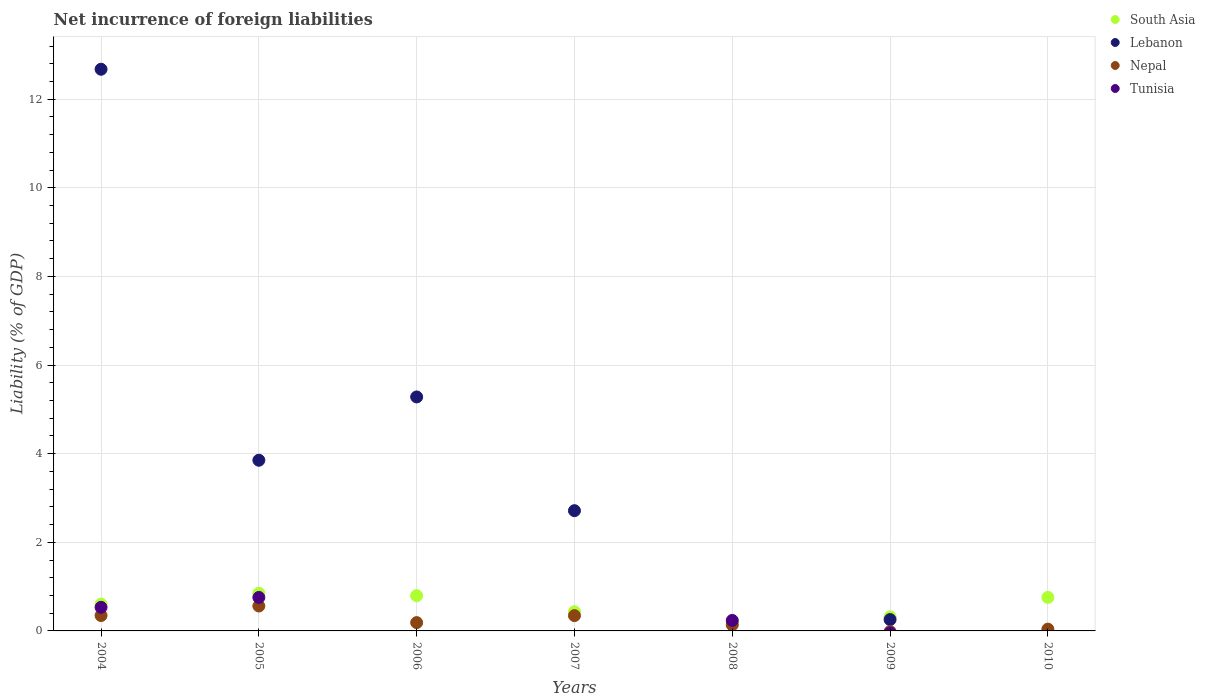How many different coloured dotlines are there?
Provide a succinct answer. 4. Across all years, what is the maximum net incurrence of foreign liabilities in Tunisia?
Provide a short and direct response. 0.76. Across all years, what is the minimum net incurrence of foreign liabilities in South Asia?
Your response must be concise. 0.2. In which year was the net incurrence of foreign liabilities in South Asia maximum?
Keep it short and to the point. 2005. What is the total net incurrence of foreign liabilities in Nepal in the graph?
Ensure brevity in your answer.  1.62. What is the difference between the net incurrence of foreign liabilities in South Asia in 2007 and that in 2010?
Offer a terse response. -0.32. What is the difference between the net incurrence of foreign liabilities in South Asia in 2005 and the net incurrence of foreign liabilities in Nepal in 2008?
Provide a short and direct response. 0.71. What is the average net incurrence of foreign liabilities in Tunisia per year?
Your answer should be very brief. 0.22. In the year 2005, what is the difference between the net incurrence of foreign liabilities in South Asia and net incurrence of foreign liabilities in Nepal?
Make the answer very short. 0.29. In how many years, is the net incurrence of foreign liabilities in South Asia greater than 12.4 %?
Offer a terse response. 0. What is the ratio of the net incurrence of foreign liabilities in Nepal in 2005 to that in 2006?
Make the answer very short. 3. Is the net incurrence of foreign liabilities in Lebanon in 2004 less than that in 2007?
Make the answer very short. No. What is the difference between the highest and the second highest net incurrence of foreign liabilities in Nepal?
Offer a very short reply. 0.21. What is the difference between the highest and the lowest net incurrence of foreign liabilities in Lebanon?
Your response must be concise. 12.68. In how many years, is the net incurrence of foreign liabilities in South Asia greater than the average net incurrence of foreign liabilities in South Asia taken over all years?
Your answer should be compact. 4. Is the sum of the net incurrence of foreign liabilities in Nepal in 2004 and 2007 greater than the maximum net incurrence of foreign liabilities in Lebanon across all years?
Ensure brevity in your answer.  No. Is it the case that in every year, the sum of the net incurrence of foreign liabilities in Tunisia and net incurrence of foreign liabilities in Lebanon  is greater than the sum of net incurrence of foreign liabilities in South Asia and net incurrence of foreign liabilities in Nepal?
Keep it short and to the point. No. Is it the case that in every year, the sum of the net incurrence of foreign liabilities in South Asia and net incurrence of foreign liabilities in Lebanon  is greater than the net incurrence of foreign liabilities in Tunisia?
Your answer should be compact. No. Is the net incurrence of foreign liabilities in Lebanon strictly greater than the net incurrence of foreign liabilities in Tunisia over the years?
Your response must be concise. No. How many years are there in the graph?
Provide a succinct answer. 7. What is the difference between two consecutive major ticks on the Y-axis?
Your response must be concise. 2. Are the values on the major ticks of Y-axis written in scientific E-notation?
Ensure brevity in your answer.  No. Does the graph contain grids?
Your answer should be compact. Yes. How are the legend labels stacked?
Give a very brief answer. Vertical. What is the title of the graph?
Give a very brief answer. Net incurrence of foreign liabilities. What is the label or title of the X-axis?
Make the answer very short. Years. What is the label or title of the Y-axis?
Your answer should be compact. Liability (% of GDP). What is the Liability (% of GDP) of South Asia in 2004?
Your answer should be compact. 0.61. What is the Liability (% of GDP) in Lebanon in 2004?
Your answer should be compact. 12.68. What is the Liability (% of GDP) of Nepal in 2004?
Your answer should be very brief. 0.35. What is the Liability (% of GDP) in Tunisia in 2004?
Ensure brevity in your answer.  0.53. What is the Liability (% of GDP) of South Asia in 2005?
Provide a short and direct response. 0.85. What is the Liability (% of GDP) in Lebanon in 2005?
Your response must be concise. 3.85. What is the Liability (% of GDP) in Nepal in 2005?
Keep it short and to the point. 0.56. What is the Liability (% of GDP) in Tunisia in 2005?
Keep it short and to the point. 0.76. What is the Liability (% of GDP) of South Asia in 2006?
Your answer should be very brief. 0.8. What is the Liability (% of GDP) in Lebanon in 2006?
Ensure brevity in your answer.  5.28. What is the Liability (% of GDP) in Nepal in 2006?
Provide a succinct answer. 0.19. What is the Liability (% of GDP) of Tunisia in 2006?
Offer a very short reply. 0. What is the Liability (% of GDP) of South Asia in 2007?
Your answer should be very brief. 0.43. What is the Liability (% of GDP) of Lebanon in 2007?
Provide a short and direct response. 2.71. What is the Liability (% of GDP) in Nepal in 2007?
Your answer should be compact. 0.35. What is the Liability (% of GDP) of Tunisia in 2007?
Provide a short and direct response. 0. What is the Liability (% of GDP) of South Asia in 2008?
Offer a very short reply. 0.2. What is the Liability (% of GDP) in Lebanon in 2008?
Ensure brevity in your answer.  0. What is the Liability (% of GDP) of Nepal in 2008?
Keep it short and to the point. 0.14. What is the Liability (% of GDP) in Tunisia in 2008?
Your response must be concise. 0.24. What is the Liability (% of GDP) in South Asia in 2009?
Ensure brevity in your answer.  0.32. What is the Liability (% of GDP) in Lebanon in 2009?
Offer a terse response. 0.26. What is the Liability (% of GDP) in Nepal in 2009?
Provide a short and direct response. 0. What is the Liability (% of GDP) in South Asia in 2010?
Your answer should be very brief. 0.76. What is the Liability (% of GDP) in Lebanon in 2010?
Make the answer very short. 0. What is the Liability (% of GDP) in Nepal in 2010?
Keep it short and to the point. 0.04. What is the Liability (% of GDP) of Tunisia in 2010?
Your response must be concise. 0. Across all years, what is the maximum Liability (% of GDP) of South Asia?
Provide a short and direct response. 0.85. Across all years, what is the maximum Liability (% of GDP) of Lebanon?
Your answer should be very brief. 12.68. Across all years, what is the maximum Liability (% of GDP) of Nepal?
Ensure brevity in your answer.  0.56. Across all years, what is the maximum Liability (% of GDP) in Tunisia?
Provide a succinct answer. 0.76. Across all years, what is the minimum Liability (% of GDP) in South Asia?
Your answer should be compact. 0.2. Across all years, what is the minimum Liability (% of GDP) in Nepal?
Keep it short and to the point. 0. Across all years, what is the minimum Liability (% of GDP) of Tunisia?
Ensure brevity in your answer.  0. What is the total Liability (% of GDP) of South Asia in the graph?
Make the answer very short. 3.95. What is the total Liability (% of GDP) of Lebanon in the graph?
Make the answer very short. 24.78. What is the total Liability (% of GDP) of Nepal in the graph?
Make the answer very short. 1.62. What is the total Liability (% of GDP) in Tunisia in the graph?
Provide a succinct answer. 1.52. What is the difference between the Liability (% of GDP) in South Asia in 2004 and that in 2005?
Ensure brevity in your answer.  -0.24. What is the difference between the Liability (% of GDP) of Lebanon in 2004 and that in 2005?
Offer a terse response. 8.82. What is the difference between the Liability (% of GDP) of Nepal in 2004 and that in 2005?
Make the answer very short. -0.21. What is the difference between the Liability (% of GDP) of Tunisia in 2004 and that in 2005?
Make the answer very short. -0.22. What is the difference between the Liability (% of GDP) of South Asia in 2004 and that in 2006?
Provide a short and direct response. -0.19. What is the difference between the Liability (% of GDP) of Lebanon in 2004 and that in 2006?
Keep it short and to the point. 7.4. What is the difference between the Liability (% of GDP) in Nepal in 2004 and that in 2006?
Provide a succinct answer. 0.16. What is the difference between the Liability (% of GDP) in South Asia in 2004 and that in 2007?
Keep it short and to the point. 0.17. What is the difference between the Liability (% of GDP) in Lebanon in 2004 and that in 2007?
Ensure brevity in your answer.  9.96. What is the difference between the Liability (% of GDP) of Nepal in 2004 and that in 2007?
Ensure brevity in your answer.  0. What is the difference between the Liability (% of GDP) of South Asia in 2004 and that in 2008?
Provide a succinct answer. 0.41. What is the difference between the Liability (% of GDP) of Nepal in 2004 and that in 2008?
Make the answer very short. 0.21. What is the difference between the Liability (% of GDP) in Tunisia in 2004 and that in 2008?
Provide a succinct answer. 0.3. What is the difference between the Liability (% of GDP) of South Asia in 2004 and that in 2009?
Offer a terse response. 0.29. What is the difference between the Liability (% of GDP) of Lebanon in 2004 and that in 2009?
Provide a short and direct response. 12.42. What is the difference between the Liability (% of GDP) of South Asia in 2004 and that in 2010?
Make the answer very short. -0.15. What is the difference between the Liability (% of GDP) of Nepal in 2004 and that in 2010?
Give a very brief answer. 0.31. What is the difference between the Liability (% of GDP) of South Asia in 2005 and that in 2006?
Your answer should be very brief. 0.06. What is the difference between the Liability (% of GDP) in Lebanon in 2005 and that in 2006?
Give a very brief answer. -1.43. What is the difference between the Liability (% of GDP) of Nepal in 2005 and that in 2006?
Provide a succinct answer. 0.37. What is the difference between the Liability (% of GDP) of South Asia in 2005 and that in 2007?
Make the answer very short. 0.42. What is the difference between the Liability (% of GDP) of Lebanon in 2005 and that in 2007?
Provide a succinct answer. 1.14. What is the difference between the Liability (% of GDP) of Nepal in 2005 and that in 2007?
Keep it short and to the point. 0.22. What is the difference between the Liability (% of GDP) of South Asia in 2005 and that in 2008?
Your answer should be very brief. 0.65. What is the difference between the Liability (% of GDP) in Nepal in 2005 and that in 2008?
Your response must be concise. 0.43. What is the difference between the Liability (% of GDP) of Tunisia in 2005 and that in 2008?
Offer a terse response. 0.52. What is the difference between the Liability (% of GDP) in South Asia in 2005 and that in 2009?
Your answer should be very brief. 0.53. What is the difference between the Liability (% of GDP) in Lebanon in 2005 and that in 2009?
Provide a short and direct response. 3.6. What is the difference between the Liability (% of GDP) in South Asia in 2005 and that in 2010?
Your answer should be very brief. 0.09. What is the difference between the Liability (% of GDP) in Nepal in 2005 and that in 2010?
Offer a terse response. 0.52. What is the difference between the Liability (% of GDP) in South Asia in 2006 and that in 2007?
Your answer should be very brief. 0.36. What is the difference between the Liability (% of GDP) of Lebanon in 2006 and that in 2007?
Ensure brevity in your answer.  2.57. What is the difference between the Liability (% of GDP) in Nepal in 2006 and that in 2007?
Your answer should be compact. -0.16. What is the difference between the Liability (% of GDP) of South Asia in 2006 and that in 2008?
Offer a terse response. 0.6. What is the difference between the Liability (% of GDP) in Nepal in 2006 and that in 2008?
Your answer should be compact. 0.05. What is the difference between the Liability (% of GDP) in South Asia in 2006 and that in 2009?
Give a very brief answer. 0.48. What is the difference between the Liability (% of GDP) in Lebanon in 2006 and that in 2009?
Keep it short and to the point. 5.02. What is the difference between the Liability (% of GDP) of South Asia in 2006 and that in 2010?
Your response must be concise. 0.04. What is the difference between the Liability (% of GDP) in Nepal in 2006 and that in 2010?
Your answer should be compact. 0.15. What is the difference between the Liability (% of GDP) of South Asia in 2007 and that in 2008?
Give a very brief answer. 0.24. What is the difference between the Liability (% of GDP) in Nepal in 2007 and that in 2008?
Make the answer very short. 0.21. What is the difference between the Liability (% of GDP) in South Asia in 2007 and that in 2009?
Your answer should be compact. 0.11. What is the difference between the Liability (% of GDP) of Lebanon in 2007 and that in 2009?
Provide a short and direct response. 2.46. What is the difference between the Liability (% of GDP) in South Asia in 2007 and that in 2010?
Ensure brevity in your answer.  -0.32. What is the difference between the Liability (% of GDP) of Nepal in 2007 and that in 2010?
Your answer should be compact. 0.31. What is the difference between the Liability (% of GDP) of South Asia in 2008 and that in 2009?
Make the answer very short. -0.12. What is the difference between the Liability (% of GDP) of South Asia in 2008 and that in 2010?
Your answer should be very brief. -0.56. What is the difference between the Liability (% of GDP) of Nepal in 2008 and that in 2010?
Make the answer very short. 0.1. What is the difference between the Liability (% of GDP) of South Asia in 2009 and that in 2010?
Provide a succinct answer. -0.44. What is the difference between the Liability (% of GDP) in South Asia in 2004 and the Liability (% of GDP) in Lebanon in 2005?
Your answer should be compact. -3.24. What is the difference between the Liability (% of GDP) of South Asia in 2004 and the Liability (% of GDP) of Nepal in 2005?
Your response must be concise. 0.04. What is the difference between the Liability (% of GDP) of South Asia in 2004 and the Liability (% of GDP) of Tunisia in 2005?
Your answer should be very brief. -0.15. What is the difference between the Liability (% of GDP) in Lebanon in 2004 and the Liability (% of GDP) in Nepal in 2005?
Your response must be concise. 12.11. What is the difference between the Liability (% of GDP) in Lebanon in 2004 and the Liability (% of GDP) in Tunisia in 2005?
Your answer should be compact. 11.92. What is the difference between the Liability (% of GDP) in Nepal in 2004 and the Liability (% of GDP) in Tunisia in 2005?
Your answer should be very brief. -0.41. What is the difference between the Liability (% of GDP) of South Asia in 2004 and the Liability (% of GDP) of Lebanon in 2006?
Ensure brevity in your answer.  -4.67. What is the difference between the Liability (% of GDP) of South Asia in 2004 and the Liability (% of GDP) of Nepal in 2006?
Provide a succinct answer. 0.42. What is the difference between the Liability (% of GDP) in Lebanon in 2004 and the Liability (% of GDP) in Nepal in 2006?
Provide a succinct answer. 12.49. What is the difference between the Liability (% of GDP) of South Asia in 2004 and the Liability (% of GDP) of Lebanon in 2007?
Give a very brief answer. -2.11. What is the difference between the Liability (% of GDP) of South Asia in 2004 and the Liability (% of GDP) of Nepal in 2007?
Provide a succinct answer. 0.26. What is the difference between the Liability (% of GDP) of Lebanon in 2004 and the Liability (% of GDP) of Nepal in 2007?
Ensure brevity in your answer.  12.33. What is the difference between the Liability (% of GDP) of South Asia in 2004 and the Liability (% of GDP) of Nepal in 2008?
Make the answer very short. 0.47. What is the difference between the Liability (% of GDP) of South Asia in 2004 and the Liability (% of GDP) of Tunisia in 2008?
Provide a succinct answer. 0.37. What is the difference between the Liability (% of GDP) of Lebanon in 2004 and the Liability (% of GDP) of Nepal in 2008?
Your response must be concise. 12.54. What is the difference between the Liability (% of GDP) in Lebanon in 2004 and the Liability (% of GDP) in Tunisia in 2008?
Offer a very short reply. 12.44. What is the difference between the Liability (% of GDP) of Nepal in 2004 and the Liability (% of GDP) of Tunisia in 2008?
Your answer should be compact. 0.11. What is the difference between the Liability (% of GDP) of South Asia in 2004 and the Liability (% of GDP) of Lebanon in 2009?
Offer a terse response. 0.35. What is the difference between the Liability (% of GDP) of South Asia in 2004 and the Liability (% of GDP) of Nepal in 2010?
Offer a very short reply. 0.57. What is the difference between the Liability (% of GDP) in Lebanon in 2004 and the Liability (% of GDP) in Nepal in 2010?
Keep it short and to the point. 12.64. What is the difference between the Liability (% of GDP) of South Asia in 2005 and the Liability (% of GDP) of Lebanon in 2006?
Ensure brevity in your answer.  -4.43. What is the difference between the Liability (% of GDP) of South Asia in 2005 and the Liability (% of GDP) of Nepal in 2006?
Offer a very short reply. 0.66. What is the difference between the Liability (% of GDP) in Lebanon in 2005 and the Liability (% of GDP) in Nepal in 2006?
Your answer should be very brief. 3.66. What is the difference between the Liability (% of GDP) of South Asia in 2005 and the Liability (% of GDP) of Lebanon in 2007?
Offer a very short reply. -1.86. What is the difference between the Liability (% of GDP) of South Asia in 2005 and the Liability (% of GDP) of Nepal in 2007?
Offer a terse response. 0.5. What is the difference between the Liability (% of GDP) of Lebanon in 2005 and the Liability (% of GDP) of Nepal in 2007?
Your answer should be very brief. 3.51. What is the difference between the Liability (% of GDP) in South Asia in 2005 and the Liability (% of GDP) in Nepal in 2008?
Keep it short and to the point. 0.71. What is the difference between the Liability (% of GDP) in South Asia in 2005 and the Liability (% of GDP) in Tunisia in 2008?
Ensure brevity in your answer.  0.61. What is the difference between the Liability (% of GDP) in Lebanon in 2005 and the Liability (% of GDP) in Nepal in 2008?
Offer a terse response. 3.72. What is the difference between the Liability (% of GDP) of Lebanon in 2005 and the Liability (% of GDP) of Tunisia in 2008?
Give a very brief answer. 3.61. What is the difference between the Liability (% of GDP) in Nepal in 2005 and the Liability (% of GDP) in Tunisia in 2008?
Your answer should be compact. 0.33. What is the difference between the Liability (% of GDP) of South Asia in 2005 and the Liability (% of GDP) of Lebanon in 2009?
Your answer should be very brief. 0.59. What is the difference between the Liability (% of GDP) of South Asia in 2005 and the Liability (% of GDP) of Nepal in 2010?
Your answer should be compact. 0.81. What is the difference between the Liability (% of GDP) of Lebanon in 2005 and the Liability (% of GDP) of Nepal in 2010?
Your answer should be very brief. 3.81. What is the difference between the Liability (% of GDP) of South Asia in 2006 and the Liability (% of GDP) of Lebanon in 2007?
Provide a short and direct response. -1.92. What is the difference between the Liability (% of GDP) of South Asia in 2006 and the Liability (% of GDP) of Nepal in 2007?
Ensure brevity in your answer.  0.45. What is the difference between the Liability (% of GDP) of Lebanon in 2006 and the Liability (% of GDP) of Nepal in 2007?
Provide a short and direct response. 4.93. What is the difference between the Liability (% of GDP) in South Asia in 2006 and the Liability (% of GDP) in Nepal in 2008?
Keep it short and to the point. 0.66. What is the difference between the Liability (% of GDP) of South Asia in 2006 and the Liability (% of GDP) of Tunisia in 2008?
Offer a very short reply. 0.56. What is the difference between the Liability (% of GDP) of Lebanon in 2006 and the Liability (% of GDP) of Nepal in 2008?
Your answer should be very brief. 5.14. What is the difference between the Liability (% of GDP) of Lebanon in 2006 and the Liability (% of GDP) of Tunisia in 2008?
Ensure brevity in your answer.  5.04. What is the difference between the Liability (% of GDP) of Nepal in 2006 and the Liability (% of GDP) of Tunisia in 2008?
Your response must be concise. -0.05. What is the difference between the Liability (% of GDP) of South Asia in 2006 and the Liability (% of GDP) of Lebanon in 2009?
Provide a succinct answer. 0.54. What is the difference between the Liability (% of GDP) in South Asia in 2006 and the Liability (% of GDP) in Nepal in 2010?
Give a very brief answer. 0.75. What is the difference between the Liability (% of GDP) of Lebanon in 2006 and the Liability (% of GDP) of Nepal in 2010?
Offer a very short reply. 5.24. What is the difference between the Liability (% of GDP) in South Asia in 2007 and the Liability (% of GDP) in Nepal in 2008?
Offer a terse response. 0.3. What is the difference between the Liability (% of GDP) of South Asia in 2007 and the Liability (% of GDP) of Tunisia in 2008?
Offer a very short reply. 0.2. What is the difference between the Liability (% of GDP) of Lebanon in 2007 and the Liability (% of GDP) of Nepal in 2008?
Offer a very short reply. 2.58. What is the difference between the Liability (% of GDP) in Lebanon in 2007 and the Liability (% of GDP) in Tunisia in 2008?
Your answer should be very brief. 2.48. What is the difference between the Liability (% of GDP) in Nepal in 2007 and the Liability (% of GDP) in Tunisia in 2008?
Provide a succinct answer. 0.11. What is the difference between the Liability (% of GDP) in South Asia in 2007 and the Liability (% of GDP) in Lebanon in 2009?
Your response must be concise. 0.18. What is the difference between the Liability (% of GDP) of South Asia in 2007 and the Liability (% of GDP) of Nepal in 2010?
Give a very brief answer. 0.39. What is the difference between the Liability (% of GDP) of Lebanon in 2007 and the Liability (% of GDP) of Nepal in 2010?
Provide a short and direct response. 2.67. What is the difference between the Liability (% of GDP) of South Asia in 2008 and the Liability (% of GDP) of Lebanon in 2009?
Offer a very short reply. -0.06. What is the difference between the Liability (% of GDP) of South Asia in 2008 and the Liability (% of GDP) of Nepal in 2010?
Give a very brief answer. 0.16. What is the difference between the Liability (% of GDP) of South Asia in 2009 and the Liability (% of GDP) of Nepal in 2010?
Provide a succinct answer. 0.28. What is the difference between the Liability (% of GDP) of Lebanon in 2009 and the Liability (% of GDP) of Nepal in 2010?
Give a very brief answer. 0.22. What is the average Liability (% of GDP) of South Asia per year?
Your answer should be compact. 0.56. What is the average Liability (% of GDP) in Lebanon per year?
Provide a short and direct response. 3.54. What is the average Liability (% of GDP) of Nepal per year?
Your answer should be compact. 0.23. What is the average Liability (% of GDP) in Tunisia per year?
Your answer should be compact. 0.22. In the year 2004, what is the difference between the Liability (% of GDP) in South Asia and Liability (% of GDP) in Lebanon?
Your response must be concise. -12.07. In the year 2004, what is the difference between the Liability (% of GDP) of South Asia and Liability (% of GDP) of Nepal?
Give a very brief answer. 0.26. In the year 2004, what is the difference between the Liability (% of GDP) in South Asia and Liability (% of GDP) in Tunisia?
Provide a short and direct response. 0.07. In the year 2004, what is the difference between the Liability (% of GDP) in Lebanon and Liability (% of GDP) in Nepal?
Offer a terse response. 12.33. In the year 2004, what is the difference between the Liability (% of GDP) in Lebanon and Liability (% of GDP) in Tunisia?
Offer a very short reply. 12.14. In the year 2004, what is the difference between the Liability (% of GDP) of Nepal and Liability (% of GDP) of Tunisia?
Make the answer very short. -0.19. In the year 2005, what is the difference between the Liability (% of GDP) in South Asia and Liability (% of GDP) in Lebanon?
Give a very brief answer. -3. In the year 2005, what is the difference between the Liability (% of GDP) in South Asia and Liability (% of GDP) in Nepal?
Offer a terse response. 0.29. In the year 2005, what is the difference between the Liability (% of GDP) in South Asia and Liability (% of GDP) in Tunisia?
Offer a terse response. 0.09. In the year 2005, what is the difference between the Liability (% of GDP) in Lebanon and Liability (% of GDP) in Nepal?
Your answer should be very brief. 3.29. In the year 2005, what is the difference between the Liability (% of GDP) of Lebanon and Liability (% of GDP) of Tunisia?
Offer a terse response. 3.1. In the year 2005, what is the difference between the Liability (% of GDP) in Nepal and Liability (% of GDP) in Tunisia?
Provide a succinct answer. -0.19. In the year 2006, what is the difference between the Liability (% of GDP) of South Asia and Liability (% of GDP) of Lebanon?
Keep it short and to the point. -4.49. In the year 2006, what is the difference between the Liability (% of GDP) in South Asia and Liability (% of GDP) in Nepal?
Your response must be concise. 0.61. In the year 2006, what is the difference between the Liability (% of GDP) of Lebanon and Liability (% of GDP) of Nepal?
Provide a short and direct response. 5.09. In the year 2007, what is the difference between the Liability (% of GDP) in South Asia and Liability (% of GDP) in Lebanon?
Give a very brief answer. -2.28. In the year 2007, what is the difference between the Liability (% of GDP) of South Asia and Liability (% of GDP) of Nepal?
Your answer should be very brief. 0.09. In the year 2007, what is the difference between the Liability (% of GDP) of Lebanon and Liability (% of GDP) of Nepal?
Your response must be concise. 2.37. In the year 2008, what is the difference between the Liability (% of GDP) in South Asia and Liability (% of GDP) in Nepal?
Keep it short and to the point. 0.06. In the year 2008, what is the difference between the Liability (% of GDP) of South Asia and Liability (% of GDP) of Tunisia?
Your response must be concise. -0.04. In the year 2008, what is the difference between the Liability (% of GDP) of Nepal and Liability (% of GDP) of Tunisia?
Your answer should be very brief. -0.1. In the year 2009, what is the difference between the Liability (% of GDP) in South Asia and Liability (% of GDP) in Lebanon?
Your answer should be compact. 0.06. In the year 2010, what is the difference between the Liability (% of GDP) of South Asia and Liability (% of GDP) of Nepal?
Your answer should be compact. 0.72. What is the ratio of the Liability (% of GDP) of South Asia in 2004 to that in 2005?
Keep it short and to the point. 0.71. What is the ratio of the Liability (% of GDP) in Lebanon in 2004 to that in 2005?
Your answer should be very brief. 3.29. What is the ratio of the Liability (% of GDP) of Nepal in 2004 to that in 2005?
Provide a succinct answer. 0.62. What is the ratio of the Liability (% of GDP) of Tunisia in 2004 to that in 2005?
Provide a short and direct response. 0.7. What is the ratio of the Liability (% of GDP) of South Asia in 2004 to that in 2006?
Provide a succinct answer. 0.76. What is the ratio of the Liability (% of GDP) of Lebanon in 2004 to that in 2006?
Provide a succinct answer. 2.4. What is the ratio of the Liability (% of GDP) of Nepal in 2004 to that in 2006?
Your answer should be very brief. 1.85. What is the ratio of the Liability (% of GDP) of South Asia in 2004 to that in 2007?
Offer a terse response. 1.4. What is the ratio of the Liability (% of GDP) in Lebanon in 2004 to that in 2007?
Ensure brevity in your answer.  4.67. What is the ratio of the Liability (% of GDP) of South Asia in 2004 to that in 2008?
Keep it short and to the point. 3.1. What is the ratio of the Liability (% of GDP) of Nepal in 2004 to that in 2008?
Provide a succinct answer. 2.55. What is the ratio of the Liability (% of GDP) of Tunisia in 2004 to that in 2008?
Your answer should be very brief. 2.25. What is the ratio of the Liability (% of GDP) in South Asia in 2004 to that in 2009?
Keep it short and to the point. 1.91. What is the ratio of the Liability (% of GDP) in Lebanon in 2004 to that in 2009?
Make the answer very short. 49.56. What is the ratio of the Liability (% of GDP) of South Asia in 2004 to that in 2010?
Offer a terse response. 0.8. What is the ratio of the Liability (% of GDP) of Nepal in 2004 to that in 2010?
Give a very brief answer. 8.62. What is the ratio of the Liability (% of GDP) in South Asia in 2005 to that in 2006?
Provide a succinct answer. 1.07. What is the ratio of the Liability (% of GDP) in Lebanon in 2005 to that in 2006?
Your response must be concise. 0.73. What is the ratio of the Liability (% of GDP) of Nepal in 2005 to that in 2006?
Ensure brevity in your answer.  3. What is the ratio of the Liability (% of GDP) of South Asia in 2005 to that in 2007?
Provide a succinct answer. 1.97. What is the ratio of the Liability (% of GDP) of Lebanon in 2005 to that in 2007?
Ensure brevity in your answer.  1.42. What is the ratio of the Liability (% of GDP) in Nepal in 2005 to that in 2007?
Your response must be concise. 1.63. What is the ratio of the Liability (% of GDP) in South Asia in 2005 to that in 2008?
Your answer should be very brief. 4.35. What is the ratio of the Liability (% of GDP) in Nepal in 2005 to that in 2008?
Offer a terse response. 4.13. What is the ratio of the Liability (% of GDP) in Tunisia in 2005 to that in 2008?
Offer a very short reply. 3.19. What is the ratio of the Liability (% of GDP) of South Asia in 2005 to that in 2009?
Your answer should be very brief. 2.68. What is the ratio of the Liability (% of GDP) of Lebanon in 2005 to that in 2009?
Offer a very short reply. 15.06. What is the ratio of the Liability (% of GDP) in South Asia in 2005 to that in 2010?
Your answer should be very brief. 1.12. What is the ratio of the Liability (% of GDP) of Nepal in 2005 to that in 2010?
Provide a succinct answer. 13.96. What is the ratio of the Liability (% of GDP) of South Asia in 2006 to that in 2007?
Your answer should be very brief. 1.84. What is the ratio of the Liability (% of GDP) of Lebanon in 2006 to that in 2007?
Offer a terse response. 1.95. What is the ratio of the Liability (% of GDP) of Nepal in 2006 to that in 2007?
Make the answer very short. 0.54. What is the ratio of the Liability (% of GDP) in South Asia in 2006 to that in 2008?
Your answer should be very brief. 4.06. What is the ratio of the Liability (% of GDP) in Nepal in 2006 to that in 2008?
Your response must be concise. 1.38. What is the ratio of the Liability (% of GDP) in South Asia in 2006 to that in 2009?
Your answer should be compact. 2.51. What is the ratio of the Liability (% of GDP) in Lebanon in 2006 to that in 2009?
Keep it short and to the point. 20.65. What is the ratio of the Liability (% of GDP) in South Asia in 2006 to that in 2010?
Make the answer very short. 1.05. What is the ratio of the Liability (% of GDP) of Nepal in 2006 to that in 2010?
Your answer should be very brief. 4.66. What is the ratio of the Liability (% of GDP) in South Asia in 2007 to that in 2008?
Provide a short and direct response. 2.21. What is the ratio of the Liability (% of GDP) of Nepal in 2007 to that in 2008?
Make the answer very short. 2.54. What is the ratio of the Liability (% of GDP) of South Asia in 2007 to that in 2009?
Offer a terse response. 1.36. What is the ratio of the Liability (% of GDP) of Lebanon in 2007 to that in 2009?
Provide a short and direct response. 10.61. What is the ratio of the Liability (% of GDP) in South Asia in 2007 to that in 2010?
Keep it short and to the point. 0.57. What is the ratio of the Liability (% of GDP) in Nepal in 2007 to that in 2010?
Your response must be concise. 8.58. What is the ratio of the Liability (% of GDP) in South Asia in 2008 to that in 2009?
Offer a very short reply. 0.62. What is the ratio of the Liability (% of GDP) in South Asia in 2008 to that in 2010?
Ensure brevity in your answer.  0.26. What is the ratio of the Liability (% of GDP) in Nepal in 2008 to that in 2010?
Provide a short and direct response. 3.38. What is the ratio of the Liability (% of GDP) in South Asia in 2009 to that in 2010?
Offer a very short reply. 0.42. What is the difference between the highest and the second highest Liability (% of GDP) in South Asia?
Make the answer very short. 0.06. What is the difference between the highest and the second highest Liability (% of GDP) in Lebanon?
Your answer should be very brief. 7.4. What is the difference between the highest and the second highest Liability (% of GDP) in Nepal?
Make the answer very short. 0.21. What is the difference between the highest and the second highest Liability (% of GDP) in Tunisia?
Your answer should be very brief. 0.22. What is the difference between the highest and the lowest Liability (% of GDP) in South Asia?
Keep it short and to the point. 0.65. What is the difference between the highest and the lowest Liability (% of GDP) of Lebanon?
Your answer should be compact. 12.68. What is the difference between the highest and the lowest Liability (% of GDP) of Nepal?
Make the answer very short. 0.56. What is the difference between the highest and the lowest Liability (% of GDP) of Tunisia?
Keep it short and to the point. 0.76. 